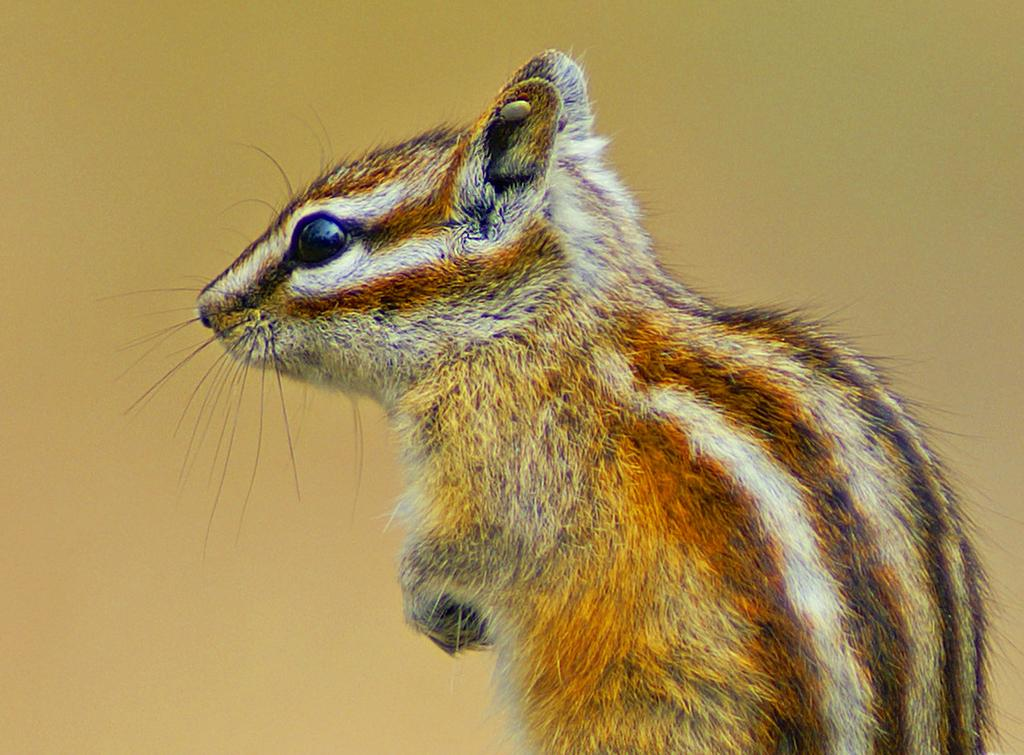What type of animal is in the image? There is a chipmunk in the image. Can you describe the background of the image? The background of the image is blurry. Where is the mailbox located in the image? There is no mailbox present in the image. What type of flower can be seen growing in the background of the image? There are no flowers visible in the image, as the background is blurry. 